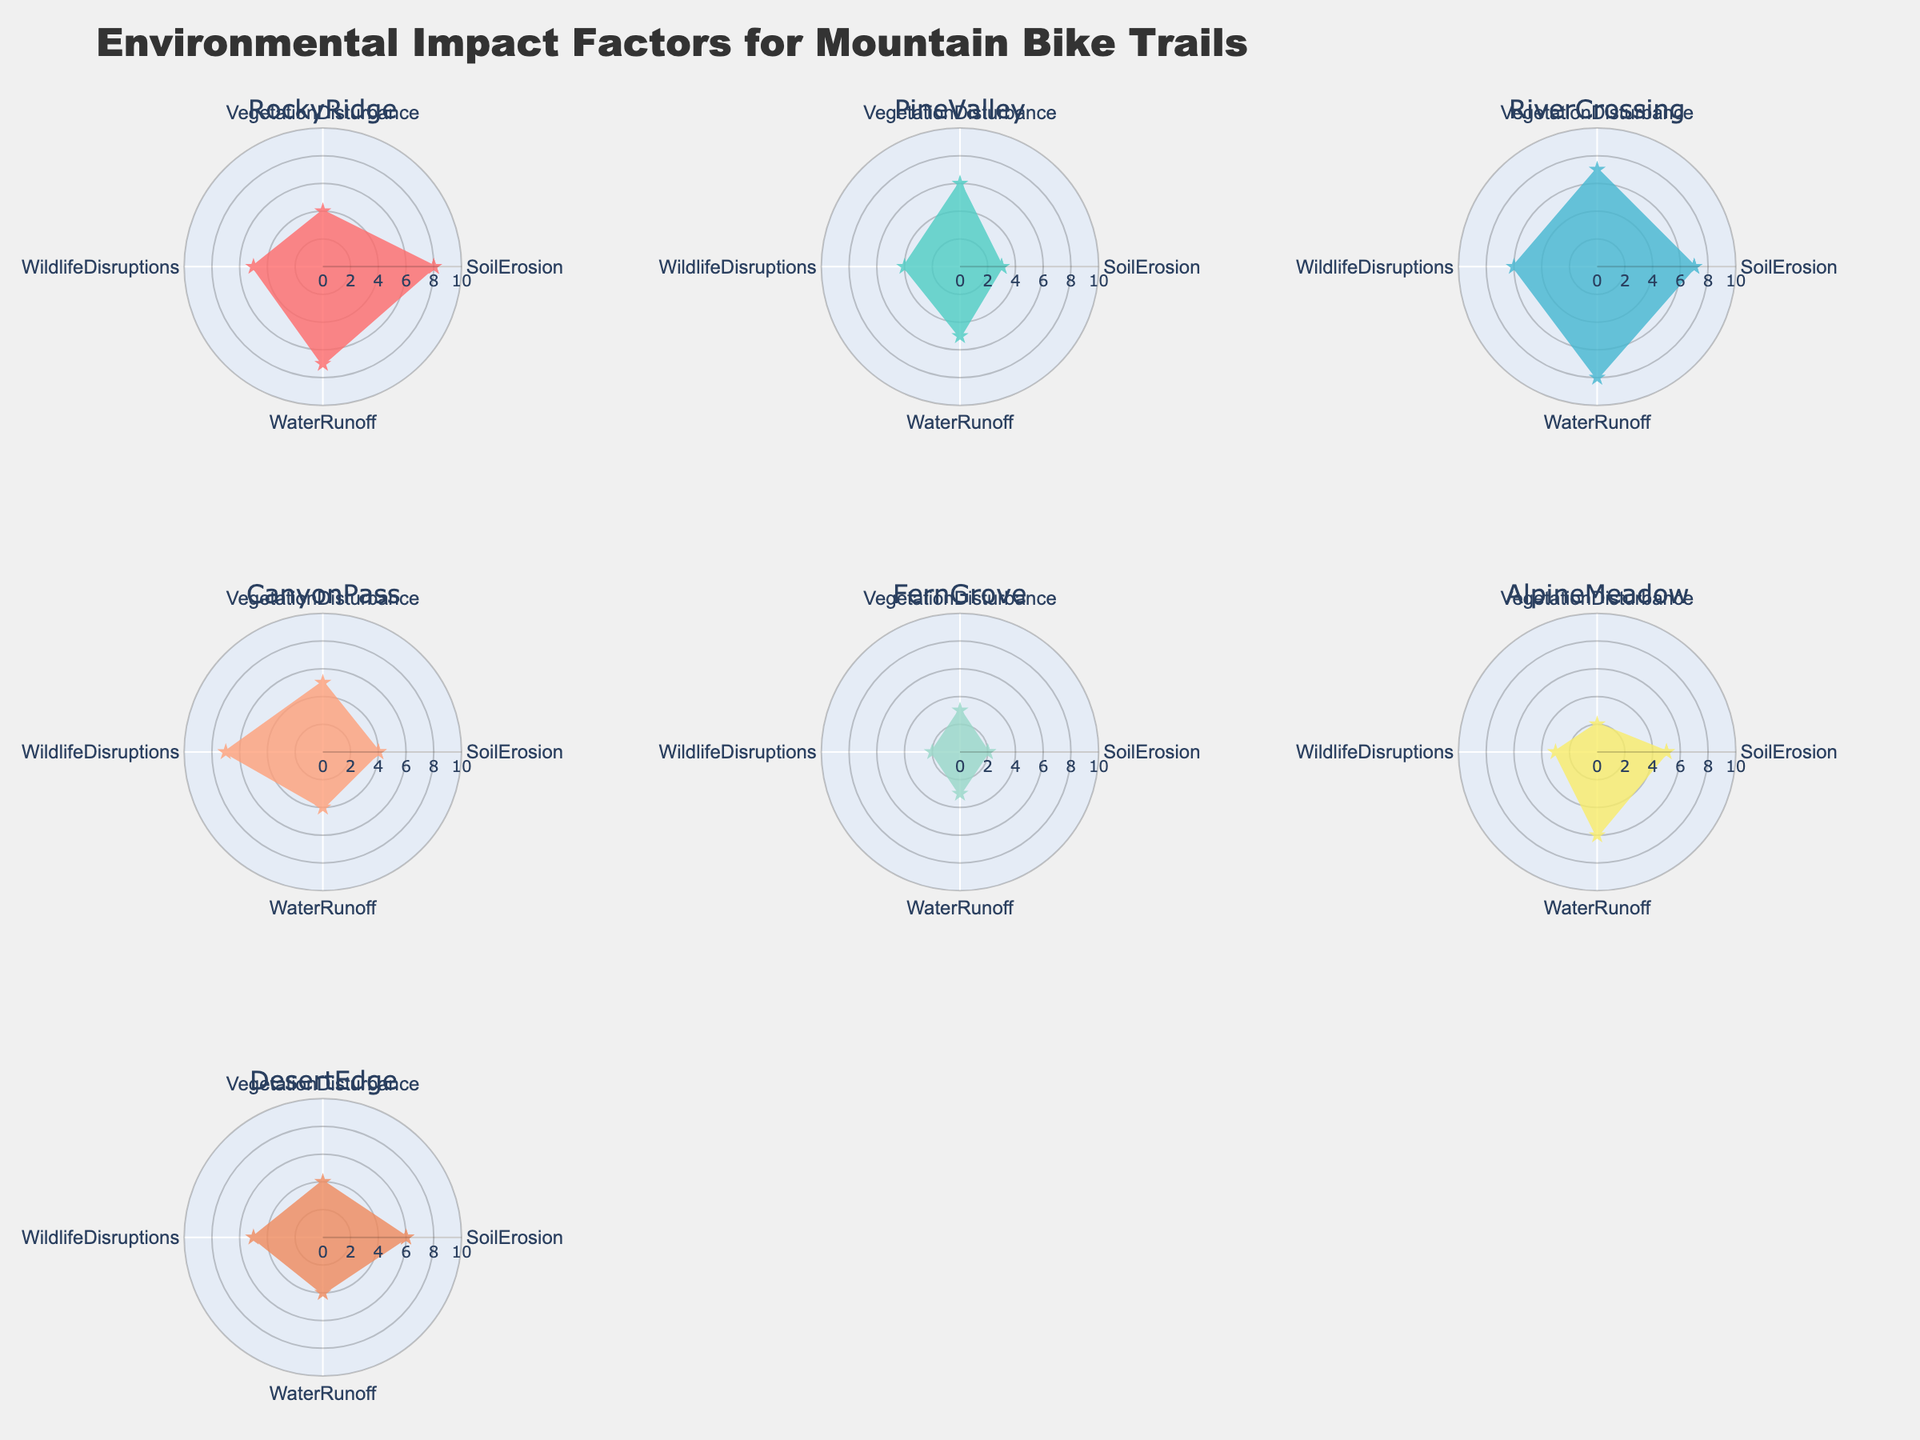Which trail section has the highest Soil Erosion? To determine this, locate the radar plot that shows the scores for each trail section and look for the section with the maximum value in the 'Soil Erosion' dimension.
Answer: Rocky Ridge Which trail section has the least impact on Wildlife Disruptions? To find the trail section with the least impact on wildlife disruptions, locate the minimum value in the 'Wildlife Disruptions' dimension across all the plots.
Answer: Fern Grove What is the average Water Runoff impact score for Alpine Meadow and Desert Edge? First, identify the Water Runoff scores for both trail sections, which are 6 for Alpine Meadow and 4 for Desert Edge. The average is calculated as (6 + 4) / 2.
Answer: 5 How does Pine Valley compare to Rocky Ridge in terms of Vegetation Disturbance? Compare the 'Vegetation Disturbance' scores of Pine Valley (6) and Rocky Ridge (4) to see which one has a higher impact.
Answer: Pine Valley has a higher Vegetation Disturbance score Which trail section has the most balanced environmental impact across all factors? A balanced impact means the scores in all dimensions are relatively close to each other. Identify the plot where the values of Soil Erosion, Vegetation Disturbance, Wildlife Disruptions, and Water Runoff are the most evenly distributed.
Answer: Canyon Pass Which trail section has the highest combined impact score (sum of all factors)? Sum the values of Soil Erosion, Vegetation Disturbance, Wildlife Disruptions, and Water Runoff for each trail section. The section with the highest sum has the highest combined impact.
Answer: River Crossing Are there any trail sections with equal scores in at least two environmental impact factors? Look through each radar chart to find any trail section where at least two of the dimensions have the same score.
Answer: Pine Valley - Vegetation Disturbance and Water Runoff both have scores of 6 What is the total Soil Erosion impact score for all trail sections combined? Add the Soil Erosion scores for all trail sections: 8 (Rocky Ridge) + 3 (Pine Valley) + 7 (River Crossing) + 4 (Canyon Pass) + 2 (Fern Grove) + 5 (Alpine Meadow) + 6 (Desert Edge).
Answer: 35 